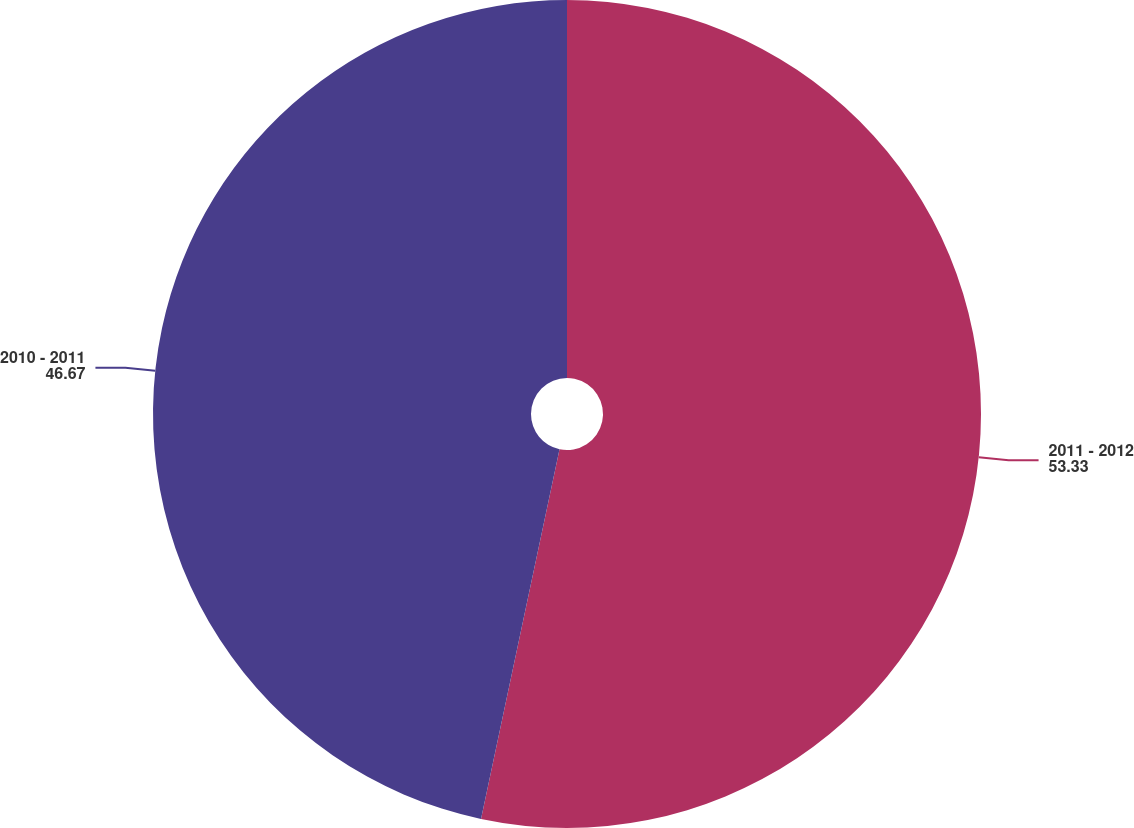Convert chart to OTSL. <chart><loc_0><loc_0><loc_500><loc_500><pie_chart><fcel>2011 - 2012<fcel>2010 - 2011<nl><fcel>53.33%<fcel>46.67%<nl></chart> 